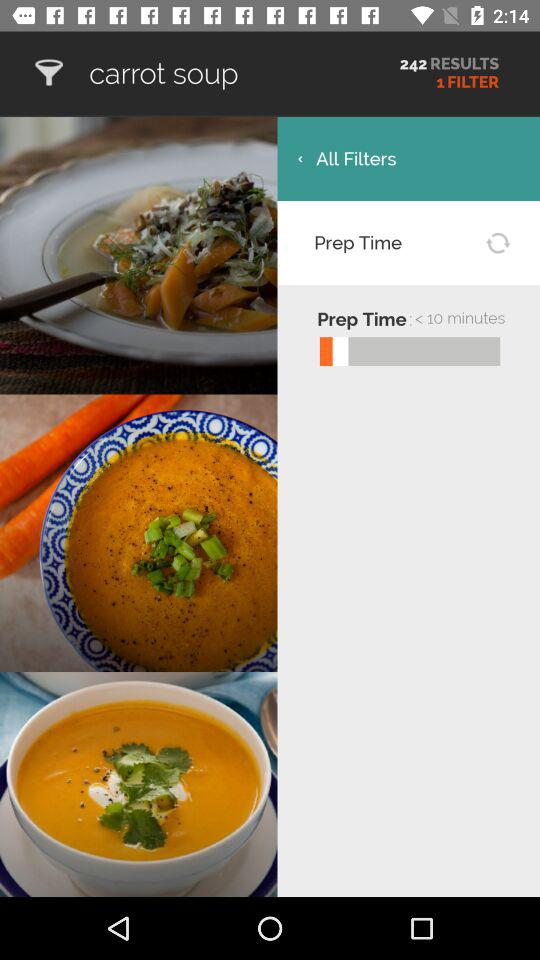What is the preparation time? The preparation time is less than 10 minutes. 